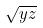<formula> <loc_0><loc_0><loc_500><loc_500>\sqrt { y z }</formula> 